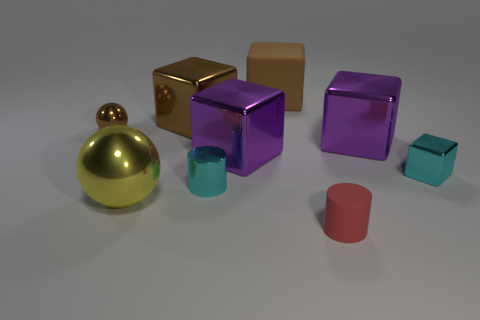What are the possible materials that the glossy purple cube could be made of? Given its glossy appearance, the purple cube could be made of a variety of materials such as polished plastic, coated metal, or even a reflective ceramic. The material would likely be smooth and durable to maintain that high shine. 